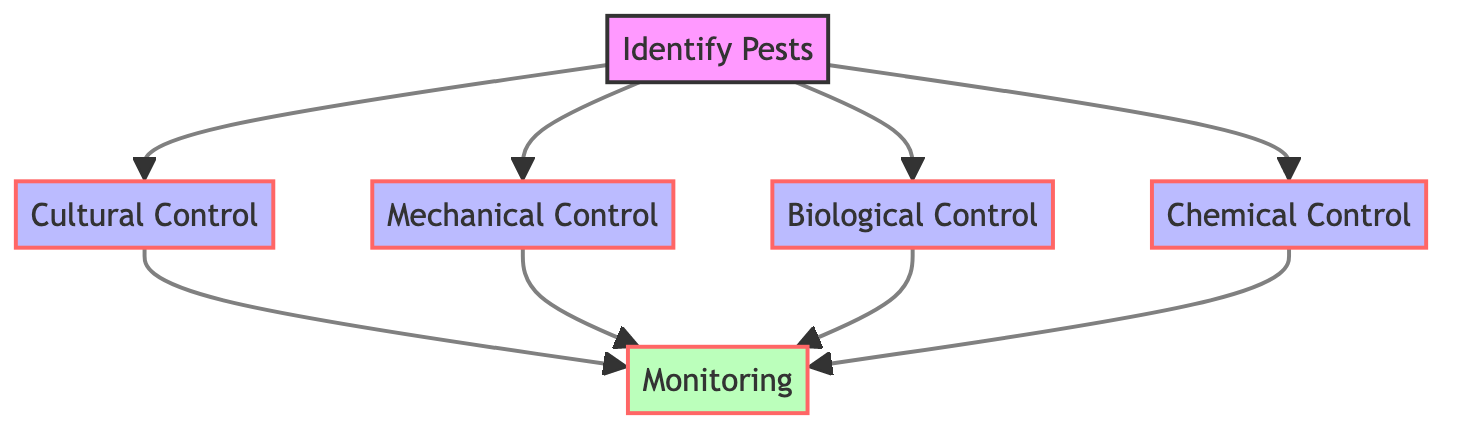What is the total number of nodes in the diagram? The diagram contains six nodes: Identify Pests, Cultural Control, Mechanical Control, Biological Control, Chemical Control, and Monitoring. Count all these unique nodes to determine the total.
Answer: 6 Which node is directly related to Identify Pests? The nodes that directly connect to Identify Pests are Cultural Control, Mechanical Control, Biological Control, and Chemical Control. Each of these nodes is linked from Identify Pests, representing different control strategies.
Answer: Cultural Control, Mechanical Control, Biological Control, Chemical Control What are the control methods mentioned in the diagram? The control methods include Cultural Control, Mechanical Control, Biological Control, and Chemical Control. These are the nodes that derive from Identify Pests, representing different strategies for managing pest populations.
Answer: Cultural Control, Mechanical Control, Biological Control, Chemical Control How many edges connect to the Monitoring node? There are four edges connecting to the Monitoring node, indicating that it is the endpoint of all control methods: Cultural Control, Mechanical Control, Biological Control, and Chemical Control. Count the directed connections that lead into the Monitoring node.
Answer: 4 Which method links to Monitoring through Cultural Control? Cultural Control links to Monitoring. This connection shows that after implementing cultural control practices, monitoring is necessary to check their effectiveness in managing pests.
Answer: Monitoring What is the sequence of steps from identifying pests to monitoring? The sequence starts with Identify Pests, which connects to Cultural Control, Mechanical Control, Biological Control, and Chemical Control. Each of these methods then connects to the Monitoring node, indicating a flow from identification to control and then to monitoring.
Answer: Identify Pests → Cultural Control/Mechanical Control/Biological Control/Chemical Control → Monitoring Which control method is used as a last resort? Chemical Control is identified as the last resort for managing pest outbreaks when other methods may not suffice. This indicates its role in the hierarchy of pest management strategies.
Answer: Chemical Control What is a key action associated with Mechanical Control? The key actions associated with Mechanical Control include handpicking, traps, and barriers, which are physical methods utilized to manage pests. These actions are part of the description provided within the node.
Answer: Handpicking, traps, barriers 